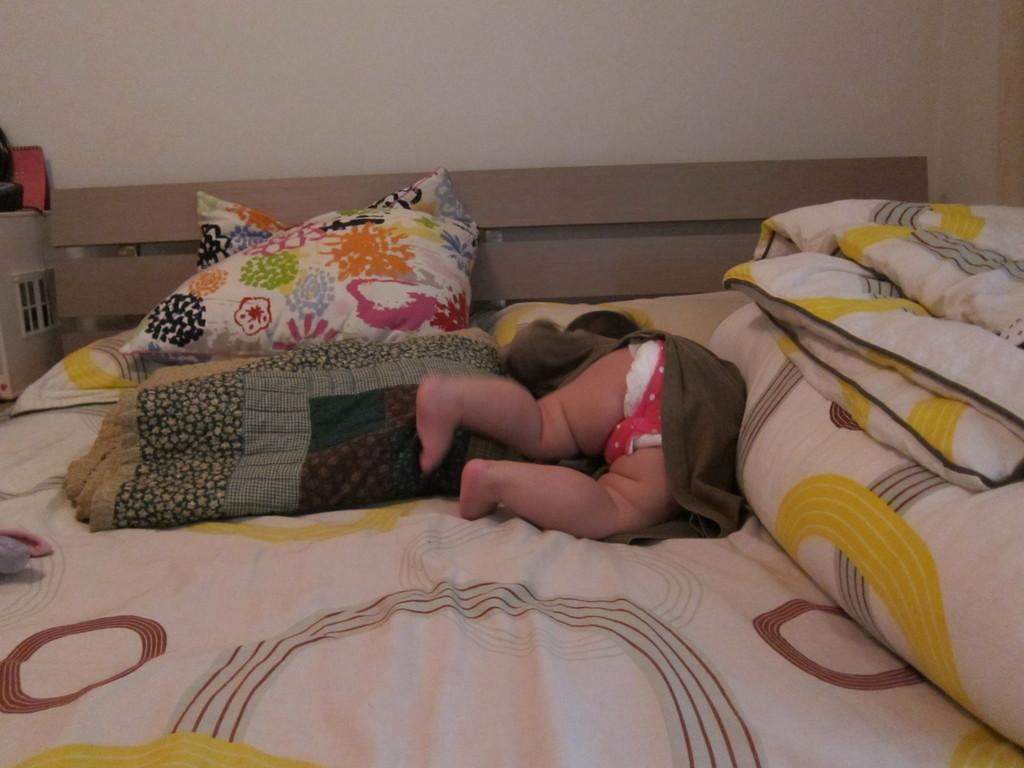What is the main subject of the image? The main subject of the image is a kid. What is the kid doing in the image? The kid is playing on a bed. How many dinosaurs are present in the image? There are no dinosaurs present in the image; it features a kid playing on a bed. What type of change does the kid undergo in the image? The kid does not undergo any change in the image; they are simply playing on a bed. 